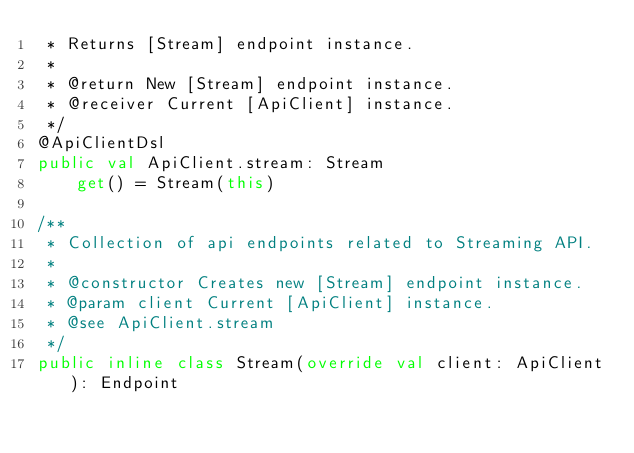Convert code to text. <code><loc_0><loc_0><loc_500><loc_500><_Kotlin_> * Returns [Stream] endpoint instance.
 *
 * @return New [Stream] endpoint instance.
 * @receiver Current [ApiClient] instance.
 */
@ApiClientDsl
public val ApiClient.stream: Stream
    get() = Stream(this)

/**
 * Collection of api endpoints related to Streaming API.
 *
 * @constructor Creates new [Stream] endpoint instance.
 * @param client Current [ApiClient] instance.
 * @see ApiClient.stream
 */
public inline class Stream(override val client: ApiClient): Endpoint
</code> 